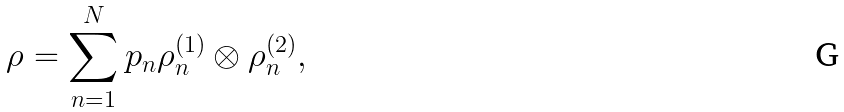Convert formula to latex. <formula><loc_0><loc_0><loc_500><loc_500>\rho = \sum _ { n = 1 } ^ { N } p _ { n } \rho _ { n } ^ { ( 1 ) } \otimes \rho _ { n } ^ { ( 2 ) } ,</formula> 